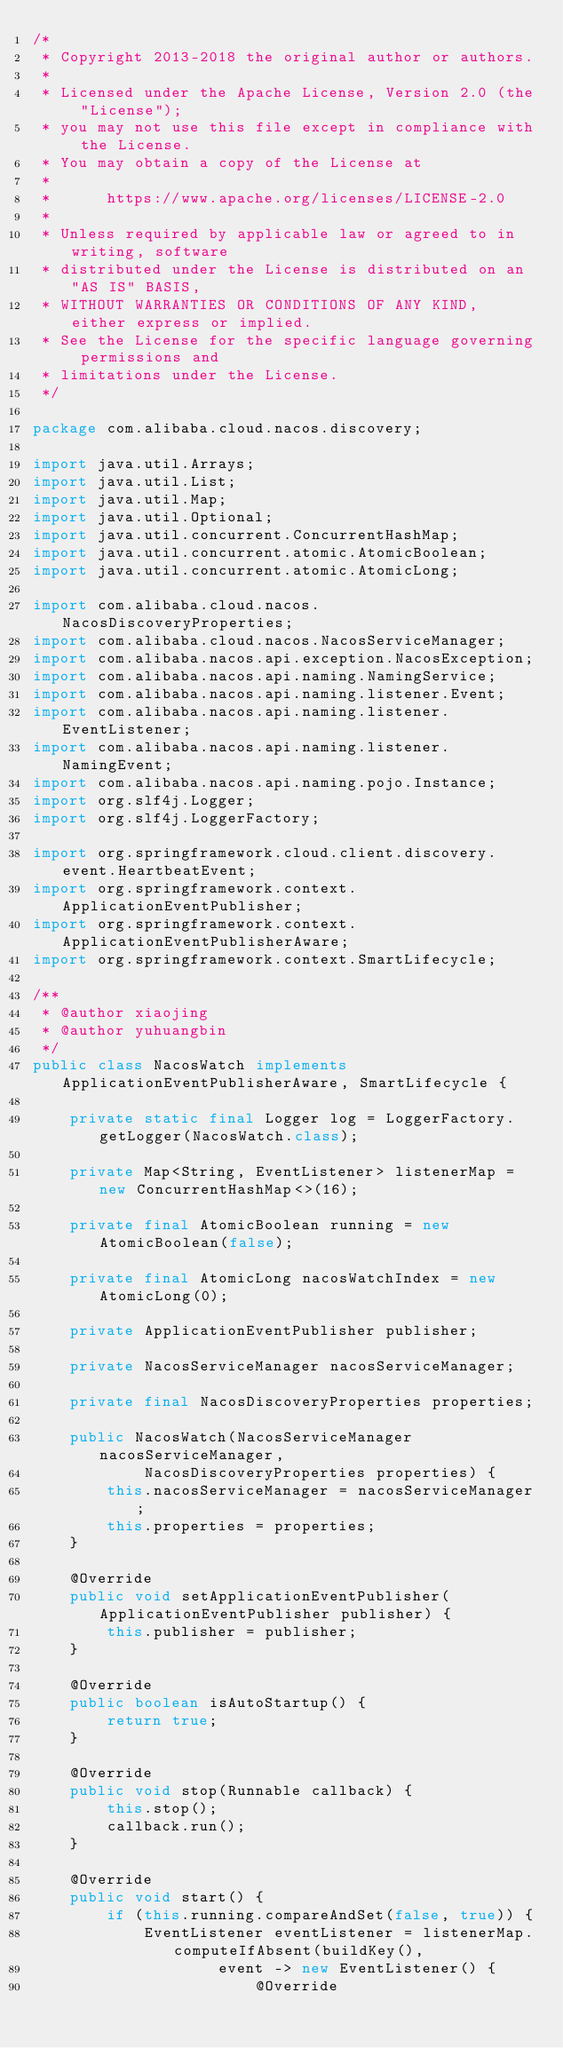<code> <loc_0><loc_0><loc_500><loc_500><_Java_>/*
 * Copyright 2013-2018 the original author or authors.
 *
 * Licensed under the Apache License, Version 2.0 (the "License");
 * you may not use this file except in compliance with the License.
 * You may obtain a copy of the License at
 *
 *      https://www.apache.org/licenses/LICENSE-2.0
 *
 * Unless required by applicable law or agreed to in writing, software
 * distributed under the License is distributed on an "AS IS" BASIS,
 * WITHOUT WARRANTIES OR CONDITIONS OF ANY KIND, either express or implied.
 * See the License for the specific language governing permissions and
 * limitations under the License.
 */

package com.alibaba.cloud.nacos.discovery;

import java.util.Arrays;
import java.util.List;
import java.util.Map;
import java.util.Optional;
import java.util.concurrent.ConcurrentHashMap;
import java.util.concurrent.atomic.AtomicBoolean;
import java.util.concurrent.atomic.AtomicLong;

import com.alibaba.cloud.nacos.NacosDiscoveryProperties;
import com.alibaba.cloud.nacos.NacosServiceManager;
import com.alibaba.nacos.api.exception.NacosException;
import com.alibaba.nacos.api.naming.NamingService;
import com.alibaba.nacos.api.naming.listener.Event;
import com.alibaba.nacos.api.naming.listener.EventListener;
import com.alibaba.nacos.api.naming.listener.NamingEvent;
import com.alibaba.nacos.api.naming.pojo.Instance;
import org.slf4j.Logger;
import org.slf4j.LoggerFactory;

import org.springframework.cloud.client.discovery.event.HeartbeatEvent;
import org.springframework.context.ApplicationEventPublisher;
import org.springframework.context.ApplicationEventPublisherAware;
import org.springframework.context.SmartLifecycle;

/**
 * @author xiaojing
 * @author yuhuangbin
 */
public class NacosWatch implements ApplicationEventPublisherAware, SmartLifecycle {

	private static final Logger log = LoggerFactory.getLogger(NacosWatch.class);

	private Map<String, EventListener> listenerMap = new ConcurrentHashMap<>(16);

	private final AtomicBoolean running = new AtomicBoolean(false);

	private final AtomicLong nacosWatchIndex = new AtomicLong(0);

	private ApplicationEventPublisher publisher;

	private NacosServiceManager nacosServiceManager;

	private final NacosDiscoveryProperties properties;

	public NacosWatch(NacosServiceManager nacosServiceManager,
			NacosDiscoveryProperties properties) {
		this.nacosServiceManager = nacosServiceManager;
		this.properties = properties;
	}

	@Override
	public void setApplicationEventPublisher(ApplicationEventPublisher publisher) {
		this.publisher = publisher;
	}

	@Override
	public boolean isAutoStartup() {
		return true;
	}

	@Override
	public void stop(Runnable callback) {
		this.stop();
		callback.run();
	}

	@Override
	public void start() {
		if (this.running.compareAndSet(false, true)) {
			EventListener eventListener = listenerMap.computeIfAbsent(buildKey(),
					event -> new EventListener() {
						@Override</code> 